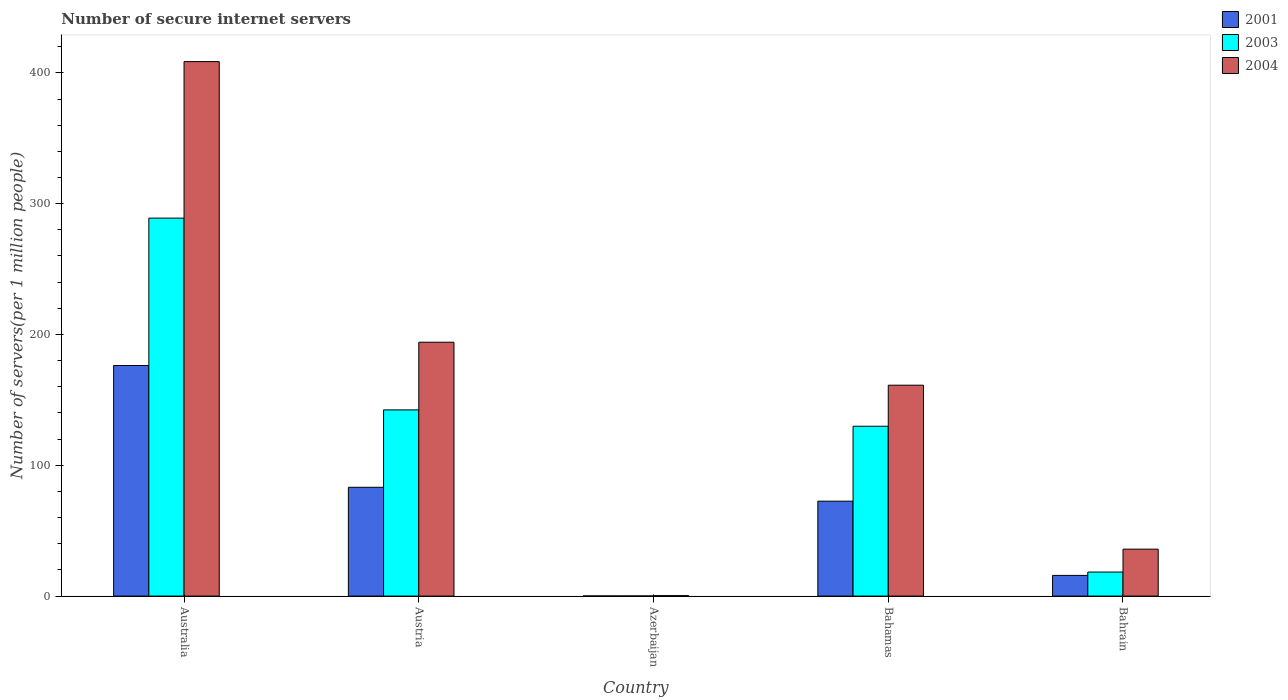How many bars are there on the 4th tick from the left?
Provide a succinct answer. 3. What is the label of the 1st group of bars from the left?
Provide a succinct answer. Australia. In how many cases, is the number of bars for a given country not equal to the number of legend labels?
Keep it short and to the point. 0. What is the number of secure internet servers in 2001 in Azerbaijan?
Offer a terse response. 0.12. Across all countries, what is the maximum number of secure internet servers in 2003?
Offer a very short reply. 288.96. Across all countries, what is the minimum number of secure internet servers in 2003?
Your response must be concise. 0.12. In which country was the number of secure internet servers in 2003 maximum?
Your answer should be compact. Australia. In which country was the number of secure internet servers in 2003 minimum?
Provide a short and direct response. Azerbaijan. What is the total number of secure internet servers in 2001 in the graph?
Ensure brevity in your answer.  347.99. What is the difference between the number of secure internet servers in 2001 in Azerbaijan and that in Bahrain?
Your response must be concise. -15.71. What is the difference between the number of secure internet servers in 2003 in Australia and the number of secure internet servers in 2001 in Bahrain?
Offer a terse response. 273.13. What is the average number of secure internet servers in 2004 per country?
Your response must be concise. 160.03. What is the difference between the number of secure internet servers of/in 2004 and number of secure internet servers of/in 2001 in Australia?
Your response must be concise. 232.32. In how many countries, is the number of secure internet servers in 2003 greater than 300?
Provide a succinct answer. 0. What is the ratio of the number of secure internet servers in 2004 in Azerbaijan to that in Bahamas?
Ensure brevity in your answer.  0. What is the difference between the highest and the second highest number of secure internet servers in 2003?
Keep it short and to the point. 159.11. What is the difference between the highest and the lowest number of secure internet servers in 2003?
Your answer should be compact. 288.84. Is the sum of the number of secure internet servers in 2001 in Austria and Azerbaijan greater than the maximum number of secure internet servers in 2003 across all countries?
Make the answer very short. No. What does the 3rd bar from the right in Austria represents?
Ensure brevity in your answer.  2001. Is it the case that in every country, the sum of the number of secure internet servers in 2003 and number of secure internet servers in 2001 is greater than the number of secure internet servers in 2004?
Your response must be concise. No. How many countries are there in the graph?
Provide a short and direct response. 5. Are the values on the major ticks of Y-axis written in scientific E-notation?
Keep it short and to the point. No. Does the graph contain grids?
Your answer should be compact. No. Where does the legend appear in the graph?
Ensure brevity in your answer.  Top right. How many legend labels are there?
Give a very brief answer. 3. How are the legend labels stacked?
Offer a terse response. Vertical. What is the title of the graph?
Offer a very short reply. Number of secure internet servers. What is the label or title of the Y-axis?
Offer a very short reply. Number of servers(per 1 million people). What is the Number of servers(per 1 million people) of 2001 in Australia?
Give a very brief answer. 176.27. What is the Number of servers(per 1 million people) in 2003 in Australia?
Your answer should be very brief. 288.96. What is the Number of servers(per 1 million people) in 2004 in Australia?
Offer a terse response. 408.6. What is the Number of servers(per 1 million people) of 2001 in Austria?
Your response must be concise. 83.19. What is the Number of servers(per 1 million people) in 2003 in Austria?
Keep it short and to the point. 142.34. What is the Number of servers(per 1 million people) of 2004 in Austria?
Offer a terse response. 194.08. What is the Number of servers(per 1 million people) of 2001 in Azerbaijan?
Provide a succinct answer. 0.12. What is the Number of servers(per 1 million people) in 2003 in Azerbaijan?
Provide a succinct answer. 0.12. What is the Number of servers(per 1 million people) in 2004 in Azerbaijan?
Your answer should be compact. 0.36. What is the Number of servers(per 1 million people) in 2001 in Bahamas?
Offer a very short reply. 72.57. What is the Number of servers(per 1 million people) of 2003 in Bahamas?
Offer a very short reply. 129.85. What is the Number of servers(per 1 million people) of 2004 in Bahamas?
Your answer should be very brief. 161.22. What is the Number of servers(per 1 million people) of 2001 in Bahrain?
Provide a short and direct response. 15.83. What is the Number of servers(per 1 million people) of 2003 in Bahrain?
Give a very brief answer. 18.38. What is the Number of servers(per 1 million people) of 2004 in Bahrain?
Your response must be concise. 35.89. Across all countries, what is the maximum Number of servers(per 1 million people) of 2001?
Keep it short and to the point. 176.27. Across all countries, what is the maximum Number of servers(per 1 million people) in 2003?
Give a very brief answer. 288.96. Across all countries, what is the maximum Number of servers(per 1 million people) in 2004?
Your answer should be very brief. 408.6. Across all countries, what is the minimum Number of servers(per 1 million people) in 2001?
Offer a terse response. 0.12. Across all countries, what is the minimum Number of servers(per 1 million people) in 2003?
Make the answer very short. 0.12. Across all countries, what is the minimum Number of servers(per 1 million people) in 2004?
Make the answer very short. 0.36. What is the total Number of servers(per 1 million people) of 2001 in the graph?
Your answer should be very brief. 347.99. What is the total Number of servers(per 1 million people) in 2003 in the graph?
Give a very brief answer. 579.65. What is the total Number of servers(per 1 million people) of 2004 in the graph?
Your response must be concise. 800.15. What is the difference between the Number of servers(per 1 million people) in 2001 in Australia and that in Austria?
Offer a terse response. 93.09. What is the difference between the Number of servers(per 1 million people) of 2003 in Australia and that in Austria?
Your answer should be very brief. 146.62. What is the difference between the Number of servers(per 1 million people) in 2004 in Australia and that in Austria?
Offer a very short reply. 214.52. What is the difference between the Number of servers(per 1 million people) in 2001 in Australia and that in Azerbaijan?
Offer a terse response. 176.15. What is the difference between the Number of servers(per 1 million people) in 2003 in Australia and that in Azerbaijan?
Your answer should be very brief. 288.84. What is the difference between the Number of servers(per 1 million people) in 2004 in Australia and that in Azerbaijan?
Your answer should be very brief. 408.24. What is the difference between the Number of servers(per 1 million people) of 2001 in Australia and that in Bahamas?
Keep it short and to the point. 103.7. What is the difference between the Number of servers(per 1 million people) in 2003 in Australia and that in Bahamas?
Your response must be concise. 159.11. What is the difference between the Number of servers(per 1 million people) in 2004 in Australia and that in Bahamas?
Your response must be concise. 247.38. What is the difference between the Number of servers(per 1 million people) of 2001 in Australia and that in Bahrain?
Provide a short and direct response. 160.44. What is the difference between the Number of servers(per 1 million people) of 2003 in Australia and that in Bahrain?
Offer a terse response. 270.58. What is the difference between the Number of servers(per 1 million people) in 2004 in Australia and that in Bahrain?
Your answer should be compact. 372.71. What is the difference between the Number of servers(per 1 million people) in 2001 in Austria and that in Azerbaijan?
Your answer should be very brief. 83.06. What is the difference between the Number of servers(per 1 million people) of 2003 in Austria and that in Azerbaijan?
Provide a short and direct response. 142.22. What is the difference between the Number of servers(per 1 million people) of 2004 in Austria and that in Azerbaijan?
Ensure brevity in your answer.  193.72. What is the difference between the Number of servers(per 1 million people) in 2001 in Austria and that in Bahamas?
Give a very brief answer. 10.61. What is the difference between the Number of servers(per 1 million people) of 2003 in Austria and that in Bahamas?
Your answer should be very brief. 12.49. What is the difference between the Number of servers(per 1 million people) in 2004 in Austria and that in Bahamas?
Offer a terse response. 32.86. What is the difference between the Number of servers(per 1 million people) of 2001 in Austria and that in Bahrain?
Offer a very short reply. 67.36. What is the difference between the Number of servers(per 1 million people) in 2003 in Austria and that in Bahrain?
Make the answer very short. 123.96. What is the difference between the Number of servers(per 1 million people) of 2004 in Austria and that in Bahrain?
Your answer should be compact. 158.19. What is the difference between the Number of servers(per 1 million people) in 2001 in Azerbaijan and that in Bahamas?
Your answer should be compact. -72.45. What is the difference between the Number of servers(per 1 million people) of 2003 in Azerbaijan and that in Bahamas?
Offer a very short reply. -129.73. What is the difference between the Number of servers(per 1 million people) in 2004 in Azerbaijan and that in Bahamas?
Offer a very short reply. -160.86. What is the difference between the Number of servers(per 1 million people) in 2001 in Azerbaijan and that in Bahrain?
Your answer should be very brief. -15.71. What is the difference between the Number of servers(per 1 million people) of 2003 in Azerbaijan and that in Bahrain?
Your answer should be compact. -18.26. What is the difference between the Number of servers(per 1 million people) of 2004 in Azerbaijan and that in Bahrain?
Offer a very short reply. -35.53. What is the difference between the Number of servers(per 1 million people) of 2001 in Bahamas and that in Bahrain?
Make the answer very short. 56.74. What is the difference between the Number of servers(per 1 million people) in 2003 in Bahamas and that in Bahrain?
Your response must be concise. 111.46. What is the difference between the Number of servers(per 1 million people) of 2004 in Bahamas and that in Bahrain?
Offer a terse response. 125.33. What is the difference between the Number of servers(per 1 million people) in 2001 in Australia and the Number of servers(per 1 million people) in 2003 in Austria?
Offer a terse response. 33.93. What is the difference between the Number of servers(per 1 million people) in 2001 in Australia and the Number of servers(per 1 million people) in 2004 in Austria?
Make the answer very short. -17.8. What is the difference between the Number of servers(per 1 million people) in 2003 in Australia and the Number of servers(per 1 million people) in 2004 in Austria?
Offer a very short reply. 94.88. What is the difference between the Number of servers(per 1 million people) in 2001 in Australia and the Number of servers(per 1 million people) in 2003 in Azerbaijan?
Keep it short and to the point. 176.15. What is the difference between the Number of servers(per 1 million people) of 2001 in Australia and the Number of servers(per 1 million people) of 2004 in Azerbaijan?
Offer a very short reply. 175.91. What is the difference between the Number of servers(per 1 million people) in 2003 in Australia and the Number of servers(per 1 million people) in 2004 in Azerbaijan?
Give a very brief answer. 288.6. What is the difference between the Number of servers(per 1 million people) in 2001 in Australia and the Number of servers(per 1 million people) in 2003 in Bahamas?
Ensure brevity in your answer.  46.43. What is the difference between the Number of servers(per 1 million people) in 2001 in Australia and the Number of servers(per 1 million people) in 2004 in Bahamas?
Offer a terse response. 15.05. What is the difference between the Number of servers(per 1 million people) of 2003 in Australia and the Number of servers(per 1 million people) of 2004 in Bahamas?
Your answer should be compact. 127.74. What is the difference between the Number of servers(per 1 million people) in 2001 in Australia and the Number of servers(per 1 million people) in 2003 in Bahrain?
Ensure brevity in your answer.  157.89. What is the difference between the Number of servers(per 1 million people) in 2001 in Australia and the Number of servers(per 1 million people) in 2004 in Bahrain?
Your answer should be compact. 140.38. What is the difference between the Number of servers(per 1 million people) in 2003 in Australia and the Number of servers(per 1 million people) in 2004 in Bahrain?
Provide a short and direct response. 253.07. What is the difference between the Number of servers(per 1 million people) of 2001 in Austria and the Number of servers(per 1 million people) of 2003 in Azerbaijan?
Offer a terse response. 83.06. What is the difference between the Number of servers(per 1 million people) of 2001 in Austria and the Number of servers(per 1 million people) of 2004 in Azerbaijan?
Offer a terse response. 82.82. What is the difference between the Number of servers(per 1 million people) in 2003 in Austria and the Number of servers(per 1 million people) in 2004 in Azerbaijan?
Offer a very short reply. 141.98. What is the difference between the Number of servers(per 1 million people) of 2001 in Austria and the Number of servers(per 1 million people) of 2003 in Bahamas?
Make the answer very short. -46.66. What is the difference between the Number of servers(per 1 million people) in 2001 in Austria and the Number of servers(per 1 million people) in 2004 in Bahamas?
Your answer should be compact. -78.04. What is the difference between the Number of servers(per 1 million people) of 2003 in Austria and the Number of servers(per 1 million people) of 2004 in Bahamas?
Make the answer very short. -18.88. What is the difference between the Number of servers(per 1 million people) of 2001 in Austria and the Number of servers(per 1 million people) of 2003 in Bahrain?
Offer a terse response. 64.8. What is the difference between the Number of servers(per 1 million people) in 2001 in Austria and the Number of servers(per 1 million people) in 2004 in Bahrain?
Your answer should be compact. 47.29. What is the difference between the Number of servers(per 1 million people) in 2003 in Austria and the Number of servers(per 1 million people) in 2004 in Bahrain?
Make the answer very short. 106.45. What is the difference between the Number of servers(per 1 million people) in 2001 in Azerbaijan and the Number of servers(per 1 million people) in 2003 in Bahamas?
Offer a very short reply. -129.72. What is the difference between the Number of servers(per 1 million people) in 2001 in Azerbaijan and the Number of servers(per 1 million people) in 2004 in Bahamas?
Offer a terse response. -161.1. What is the difference between the Number of servers(per 1 million people) in 2003 in Azerbaijan and the Number of servers(per 1 million people) in 2004 in Bahamas?
Make the answer very short. -161.1. What is the difference between the Number of servers(per 1 million people) of 2001 in Azerbaijan and the Number of servers(per 1 million people) of 2003 in Bahrain?
Offer a terse response. -18.26. What is the difference between the Number of servers(per 1 million people) in 2001 in Azerbaijan and the Number of servers(per 1 million people) in 2004 in Bahrain?
Provide a short and direct response. -35.77. What is the difference between the Number of servers(per 1 million people) of 2003 in Azerbaijan and the Number of servers(per 1 million people) of 2004 in Bahrain?
Provide a succinct answer. -35.77. What is the difference between the Number of servers(per 1 million people) in 2001 in Bahamas and the Number of servers(per 1 million people) in 2003 in Bahrain?
Make the answer very short. 54.19. What is the difference between the Number of servers(per 1 million people) in 2001 in Bahamas and the Number of servers(per 1 million people) in 2004 in Bahrain?
Keep it short and to the point. 36.68. What is the difference between the Number of servers(per 1 million people) in 2003 in Bahamas and the Number of servers(per 1 million people) in 2004 in Bahrain?
Your answer should be compact. 93.96. What is the average Number of servers(per 1 million people) in 2001 per country?
Ensure brevity in your answer.  69.6. What is the average Number of servers(per 1 million people) of 2003 per country?
Ensure brevity in your answer.  115.93. What is the average Number of servers(per 1 million people) of 2004 per country?
Offer a terse response. 160.03. What is the difference between the Number of servers(per 1 million people) of 2001 and Number of servers(per 1 million people) of 2003 in Australia?
Give a very brief answer. -112.69. What is the difference between the Number of servers(per 1 million people) of 2001 and Number of servers(per 1 million people) of 2004 in Australia?
Keep it short and to the point. -232.32. What is the difference between the Number of servers(per 1 million people) in 2003 and Number of servers(per 1 million people) in 2004 in Australia?
Your response must be concise. -119.64. What is the difference between the Number of servers(per 1 million people) of 2001 and Number of servers(per 1 million people) of 2003 in Austria?
Keep it short and to the point. -59.15. What is the difference between the Number of servers(per 1 million people) of 2001 and Number of servers(per 1 million people) of 2004 in Austria?
Your answer should be very brief. -110.89. What is the difference between the Number of servers(per 1 million people) of 2003 and Number of servers(per 1 million people) of 2004 in Austria?
Your answer should be compact. -51.74. What is the difference between the Number of servers(per 1 million people) in 2001 and Number of servers(per 1 million people) in 2003 in Azerbaijan?
Offer a very short reply. 0. What is the difference between the Number of servers(per 1 million people) in 2001 and Number of servers(per 1 million people) in 2004 in Azerbaijan?
Keep it short and to the point. -0.24. What is the difference between the Number of servers(per 1 million people) of 2003 and Number of servers(per 1 million people) of 2004 in Azerbaijan?
Your answer should be very brief. -0.24. What is the difference between the Number of servers(per 1 million people) in 2001 and Number of servers(per 1 million people) in 2003 in Bahamas?
Offer a terse response. -57.27. What is the difference between the Number of servers(per 1 million people) in 2001 and Number of servers(per 1 million people) in 2004 in Bahamas?
Provide a short and direct response. -88.65. What is the difference between the Number of servers(per 1 million people) of 2003 and Number of servers(per 1 million people) of 2004 in Bahamas?
Keep it short and to the point. -31.37. What is the difference between the Number of servers(per 1 million people) in 2001 and Number of servers(per 1 million people) in 2003 in Bahrain?
Ensure brevity in your answer.  -2.55. What is the difference between the Number of servers(per 1 million people) of 2001 and Number of servers(per 1 million people) of 2004 in Bahrain?
Keep it short and to the point. -20.06. What is the difference between the Number of servers(per 1 million people) in 2003 and Number of servers(per 1 million people) in 2004 in Bahrain?
Offer a very short reply. -17.51. What is the ratio of the Number of servers(per 1 million people) of 2001 in Australia to that in Austria?
Provide a short and direct response. 2.12. What is the ratio of the Number of servers(per 1 million people) of 2003 in Australia to that in Austria?
Provide a succinct answer. 2.03. What is the ratio of the Number of servers(per 1 million people) in 2004 in Australia to that in Austria?
Offer a terse response. 2.11. What is the ratio of the Number of servers(per 1 million people) in 2001 in Australia to that in Azerbaijan?
Provide a succinct answer. 1429.79. What is the ratio of the Number of servers(per 1 million people) of 2003 in Australia to that in Azerbaijan?
Keep it short and to the point. 2379.34. What is the ratio of the Number of servers(per 1 million people) in 2004 in Australia to that in Azerbaijan?
Your response must be concise. 1131.34. What is the ratio of the Number of servers(per 1 million people) of 2001 in Australia to that in Bahamas?
Provide a short and direct response. 2.43. What is the ratio of the Number of servers(per 1 million people) in 2003 in Australia to that in Bahamas?
Ensure brevity in your answer.  2.23. What is the ratio of the Number of servers(per 1 million people) of 2004 in Australia to that in Bahamas?
Give a very brief answer. 2.53. What is the ratio of the Number of servers(per 1 million people) in 2001 in Australia to that in Bahrain?
Provide a succinct answer. 11.14. What is the ratio of the Number of servers(per 1 million people) of 2003 in Australia to that in Bahrain?
Ensure brevity in your answer.  15.72. What is the ratio of the Number of servers(per 1 million people) of 2004 in Australia to that in Bahrain?
Ensure brevity in your answer.  11.38. What is the ratio of the Number of servers(per 1 million people) in 2001 in Austria to that in Azerbaijan?
Make the answer very short. 674.73. What is the ratio of the Number of servers(per 1 million people) in 2003 in Austria to that in Azerbaijan?
Provide a succinct answer. 1172.04. What is the ratio of the Number of servers(per 1 million people) of 2004 in Austria to that in Azerbaijan?
Offer a terse response. 537.37. What is the ratio of the Number of servers(per 1 million people) of 2001 in Austria to that in Bahamas?
Keep it short and to the point. 1.15. What is the ratio of the Number of servers(per 1 million people) of 2003 in Austria to that in Bahamas?
Provide a short and direct response. 1.1. What is the ratio of the Number of servers(per 1 million people) in 2004 in Austria to that in Bahamas?
Ensure brevity in your answer.  1.2. What is the ratio of the Number of servers(per 1 million people) in 2001 in Austria to that in Bahrain?
Your answer should be very brief. 5.25. What is the ratio of the Number of servers(per 1 million people) in 2003 in Austria to that in Bahrain?
Provide a short and direct response. 7.74. What is the ratio of the Number of servers(per 1 million people) in 2004 in Austria to that in Bahrain?
Provide a succinct answer. 5.41. What is the ratio of the Number of servers(per 1 million people) of 2001 in Azerbaijan to that in Bahamas?
Offer a terse response. 0. What is the ratio of the Number of servers(per 1 million people) in 2003 in Azerbaijan to that in Bahamas?
Your answer should be very brief. 0. What is the ratio of the Number of servers(per 1 million people) in 2004 in Azerbaijan to that in Bahamas?
Your answer should be very brief. 0. What is the ratio of the Number of servers(per 1 million people) of 2001 in Azerbaijan to that in Bahrain?
Your answer should be compact. 0.01. What is the ratio of the Number of servers(per 1 million people) in 2003 in Azerbaijan to that in Bahrain?
Your answer should be compact. 0.01. What is the ratio of the Number of servers(per 1 million people) in 2004 in Azerbaijan to that in Bahrain?
Keep it short and to the point. 0.01. What is the ratio of the Number of servers(per 1 million people) in 2001 in Bahamas to that in Bahrain?
Give a very brief answer. 4.58. What is the ratio of the Number of servers(per 1 million people) of 2003 in Bahamas to that in Bahrain?
Your answer should be very brief. 7.06. What is the ratio of the Number of servers(per 1 million people) in 2004 in Bahamas to that in Bahrain?
Keep it short and to the point. 4.49. What is the difference between the highest and the second highest Number of servers(per 1 million people) in 2001?
Offer a terse response. 93.09. What is the difference between the highest and the second highest Number of servers(per 1 million people) in 2003?
Offer a very short reply. 146.62. What is the difference between the highest and the second highest Number of servers(per 1 million people) of 2004?
Your answer should be very brief. 214.52. What is the difference between the highest and the lowest Number of servers(per 1 million people) in 2001?
Keep it short and to the point. 176.15. What is the difference between the highest and the lowest Number of servers(per 1 million people) of 2003?
Keep it short and to the point. 288.84. What is the difference between the highest and the lowest Number of servers(per 1 million people) in 2004?
Your answer should be very brief. 408.24. 